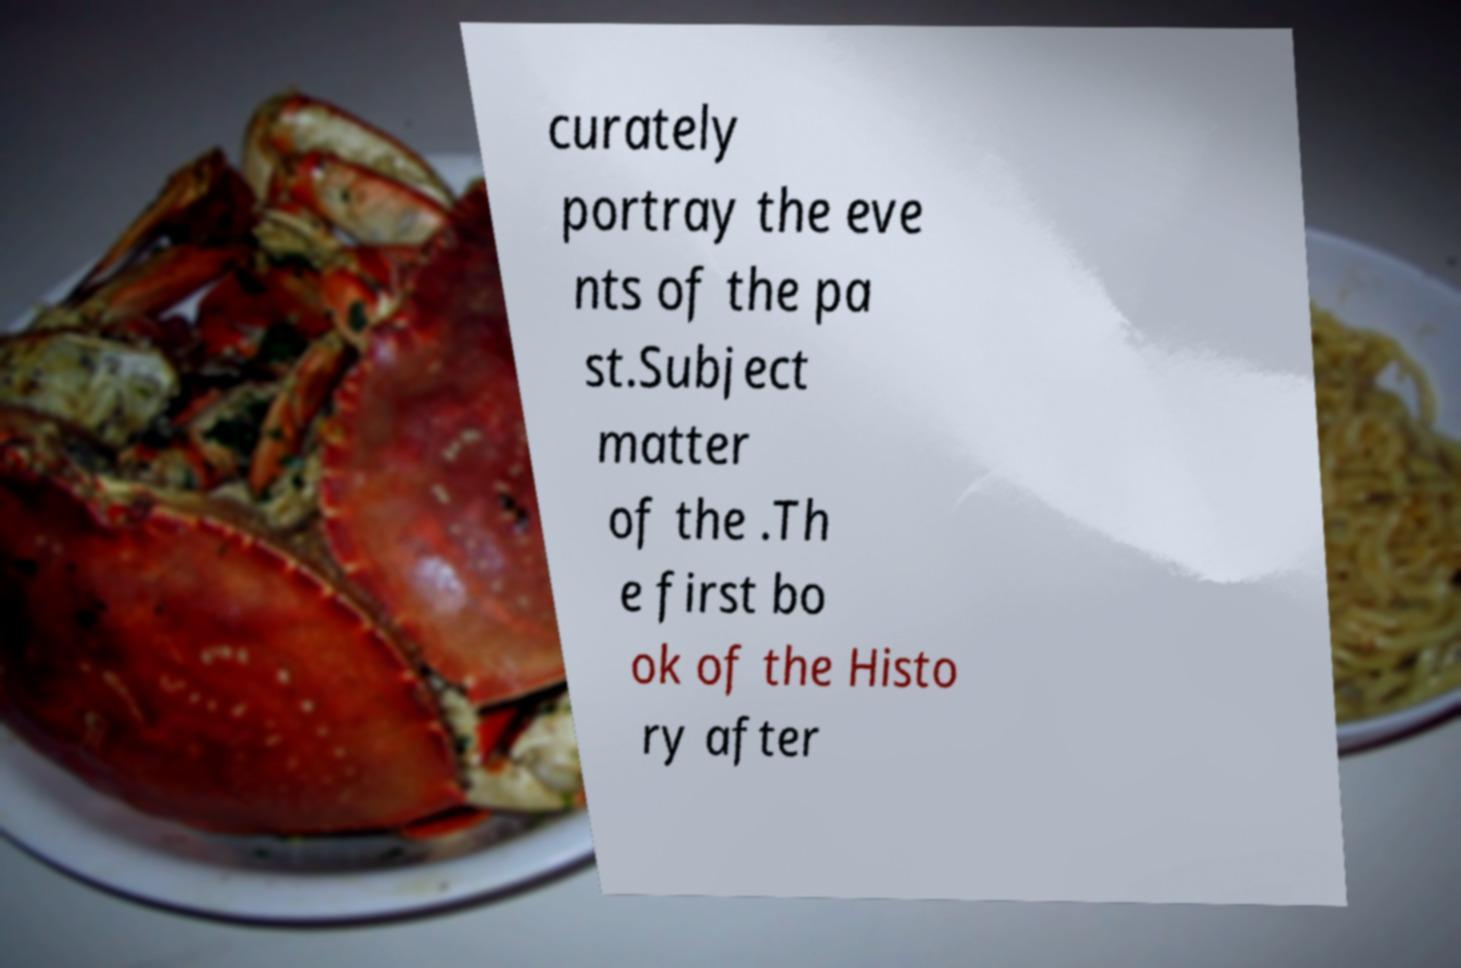Can you read and provide the text displayed in the image?This photo seems to have some interesting text. Can you extract and type it out for me? curately portray the eve nts of the pa st.Subject matter of the .Th e first bo ok of the Histo ry after 